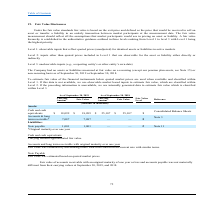According to Csp's financial document, What does a Level 1 fair value hierarchy refer to? observable inputs that reflect quoted prices (unadjusted) for identical assets or liabilities in active markets. The document states: "Level 1: observable inputs that reflect quoted prices (unadjusted) for identical assets or liabilities in active markets Level 2: inputs other than qu..." Also, What does a Level 3 fair value hierarchy refer to? unobservable inputs (e.g., a reporting entity’s or other entity’s own data). The document states: "r liability either directly or indirectly Level 3: unobservable inputs (e.g., a reporting entity’s or other entity’s own data) The Company had no asse..." Also, How is the fair value for note payable determined?  Inputs other than quoted prices included in Level 1 that are observable for the asset or liability either directly or indirectly. The document states: "assets or liabilities in active markets Level 2: inputs other than quoted prices included in Level 1 that are observable for the asset or liability ei..." Also, can you calculate: What is the difference in fair value of cash and cash equivalents between 2018 and 2019? Based on the calculation: 18,099 - 25,107 , the result is -7008 (in thousands). This is based on the information: "Cash and cash equivalents $ 18,099 $ 18,099 $ 25,107 $ 25,107 1 Consolidated Balance Sheets Cash and cash equivalents $ 18,099 $ 18,099 $ 25,107 $ 25,107 1 Consolidated Balance Sheets..." The key data points involved are: 18,099, 25,107. Also, can you calculate: What is the difference in the carrying amount and fair value of the accounts & long term receivable in 2019?  I cannot find a specific answer to this question in the financial document. Also, can you calculate: What is the percentage change in the fair value of cash and cash equivalents between 2018 and 2019? To answer this question, I need to perform calculations using the financial data. The calculation is: (18,099 - 25,107)/25,107 , which equals -27.91 (percentage). This is based on the information: "Cash and cash equivalents $ 18,099 $ 18,099 $ 25,107 $ 25,107 1 Consolidated Balance Sheets Cash and cash equivalents $ 18,099 $ 18,099 $ 25,107 $ 25,107 1 Consolidated Balance Sheets..." The key data points involved are: 18,099, 25,107. 